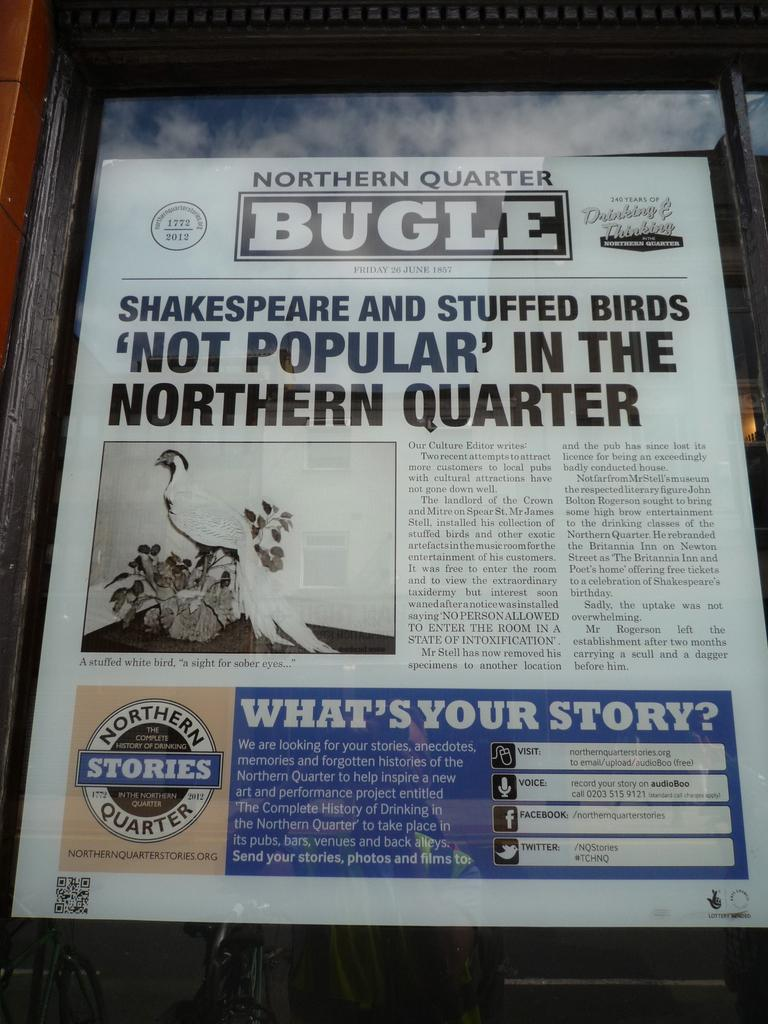What is present on the poster in the image? The poster contains text and images. Can you describe the content of the poster? The poster contains text and images, but the specific content cannot be determined from the provided facts. How many pizzas are being served by the servant in the image? There is no servant or pizzas present in the image; it only contains a poster with text and images. 